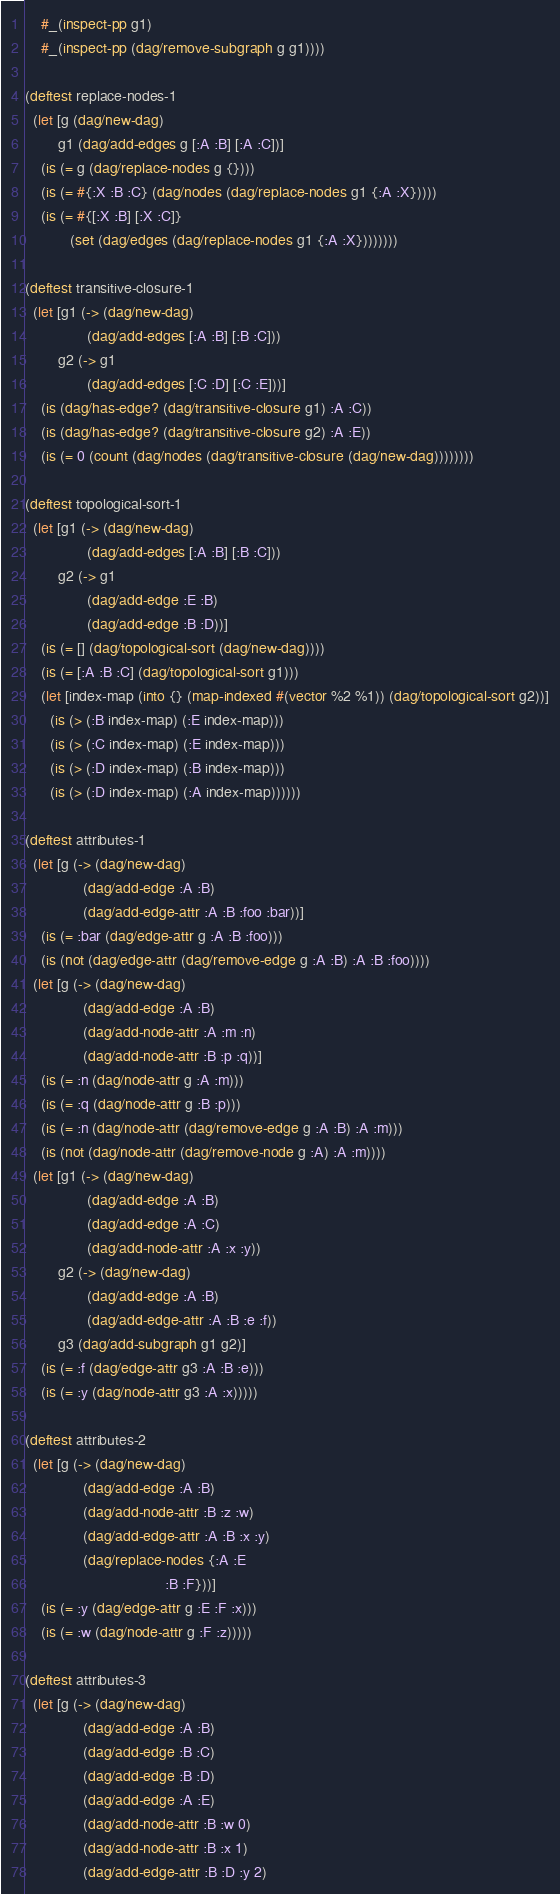<code> <loc_0><loc_0><loc_500><loc_500><_Clojure_>    #_(inspect-pp g1)
    #_(inspect-pp (dag/remove-subgraph g g1))))

(deftest replace-nodes-1
  (let [g (dag/new-dag)
        g1 (dag/add-edges g [:A :B] [:A :C])]
    (is (= g (dag/replace-nodes g {})))
    (is (= #{:X :B :C} (dag/nodes (dag/replace-nodes g1 {:A :X}))))
    (is (= #{[:X :B] [:X :C]}
           (set (dag/edges (dag/replace-nodes g1 {:A :X})))))))

(deftest transitive-closure-1
  (let [g1 (-> (dag/new-dag)
               (dag/add-edges [:A :B] [:B :C]))
        g2 (-> g1
               (dag/add-edges [:C :D] [:C :E]))]
    (is (dag/has-edge? (dag/transitive-closure g1) :A :C))
    (is (dag/has-edge? (dag/transitive-closure g2) :A :E))
    (is (= 0 (count (dag/nodes (dag/transitive-closure (dag/new-dag))))))))

(deftest topological-sort-1
  (let [g1 (-> (dag/new-dag)
               (dag/add-edges [:A :B] [:B :C]))
        g2 (-> g1
               (dag/add-edge :E :B)
               (dag/add-edge :B :D))]
    (is (= [] (dag/topological-sort (dag/new-dag))))
    (is (= [:A :B :C] (dag/topological-sort g1)))
    (let [index-map (into {} (map-indexed #(vector %2 %1)) (dag/topological-sort g2))]
      (is (> (:B index-map) (:E index-map)))
      (is (> (:C index-map) (:E index-map)))
      (is (> (:D index-map) (:B index-map)))
      (is (> (:D index-map) (:A index-map))))))

(deftest attributes-1
  (let [g (-> (dag/new-dag)
              (dag/add-edge :A :B)
              (dag/add-edge-attr :A :B :foo :bar))]
    (is (= :bar (dag/edge-attr g :A :B :foo)))
    (is (not (dag/edge-attr (dag/remove-edge g :A :B) :A :B :foo))))
  (let [g (-> (dag/new-dag)
              (dag/add-edge :A :B)
              (dag/add-node-attr :A :m :n)
              (dag/add-node-attr :B :p :q))]
    (is (= :n (dag/node-attr g :A :m)))
    (is (= :q (dag/node-attr g :B :p)))
    (is (= :n (dag/node-attr (dag/remove-edge g :A :B) :A :m)))
    (is (not (dag/node-attr (dag/remove-node g :A) :A :m))))
  (let [g1 (-> (dag/new-dag)
               (dag/add-edge :A :B)
               (dag/add-edge :A :C)
               (dag/add-node-attr :A :x :y))
        g2 (-> (dag/new-dag)
               (dag/add-edge :A :B)
               (dag/add-edge-attr :A :B :e :f))
        g3 (dag/add-subgraph g1 g2)]
    (is (= :f (dag/edge-attr g3 :A :B :e)))
    (is (= :y (dag/node-attr g3 :A :x)))))

(deftest attributes-2
  (let [g (-> (dag/new-dag)
              (dag/add-edge :A :B)
              (dag/add-node-attr :B :z :w)
              (dag/add-edge-attr :A :B :x :y)
              (dag/replace-nodes {:A :E
                                  :B :F}))]
    (is (= :y (dag/edge-attr g :E :F :x)))
    (is (= :w (dag/node-attr g :F :z)))))

(deftest attributes-3
  (let [g (-> (dag/new-dag)
              (dag/add-edge :A :B)
              (dag/add-edge :B :C)
              (dag/add-edge :B :D)
              (dag/add-edge :A :E)
              (dag/add-node-attr :B :w 0)
              (dag/add-node-attr :B :x 1)
              (dag/add-edge-attr :B :D :y 2)</code> 